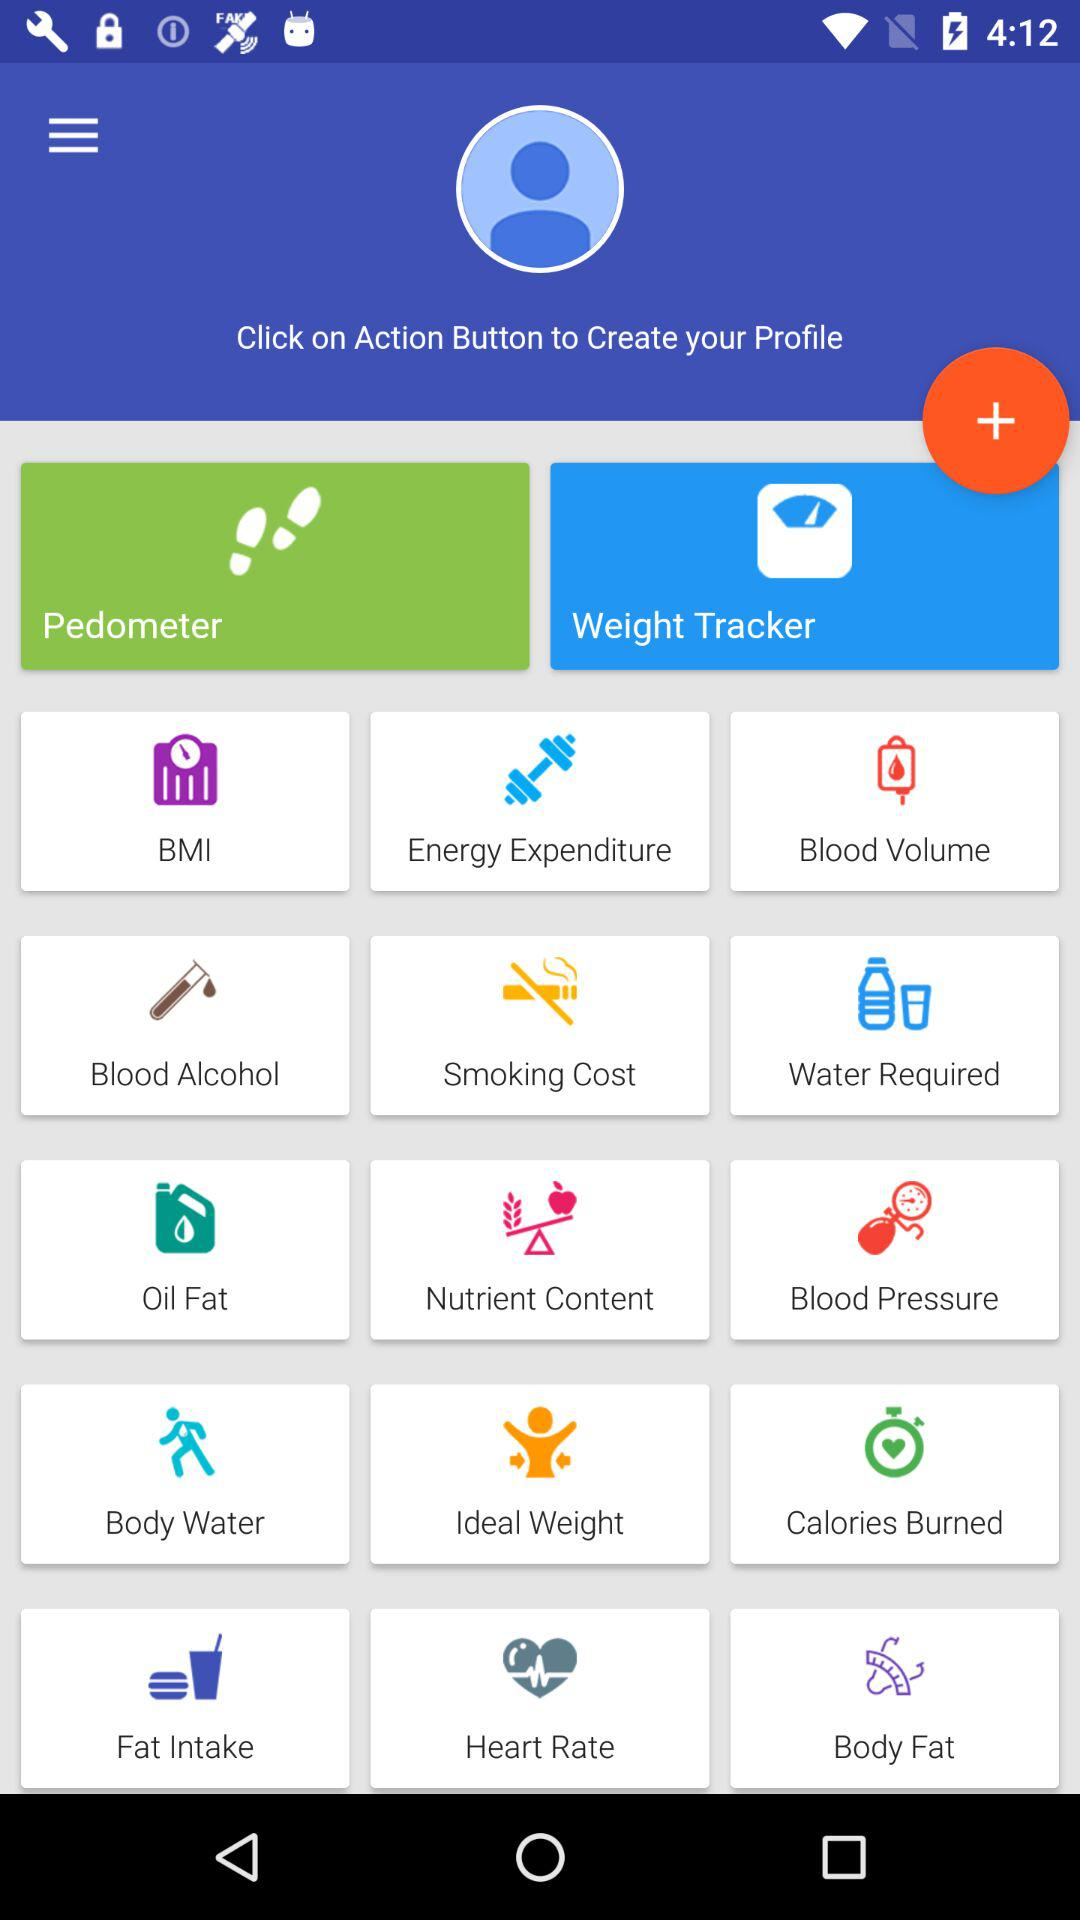What button do we need to click to create a profile? You need to click the "Action" button to create a profile. 